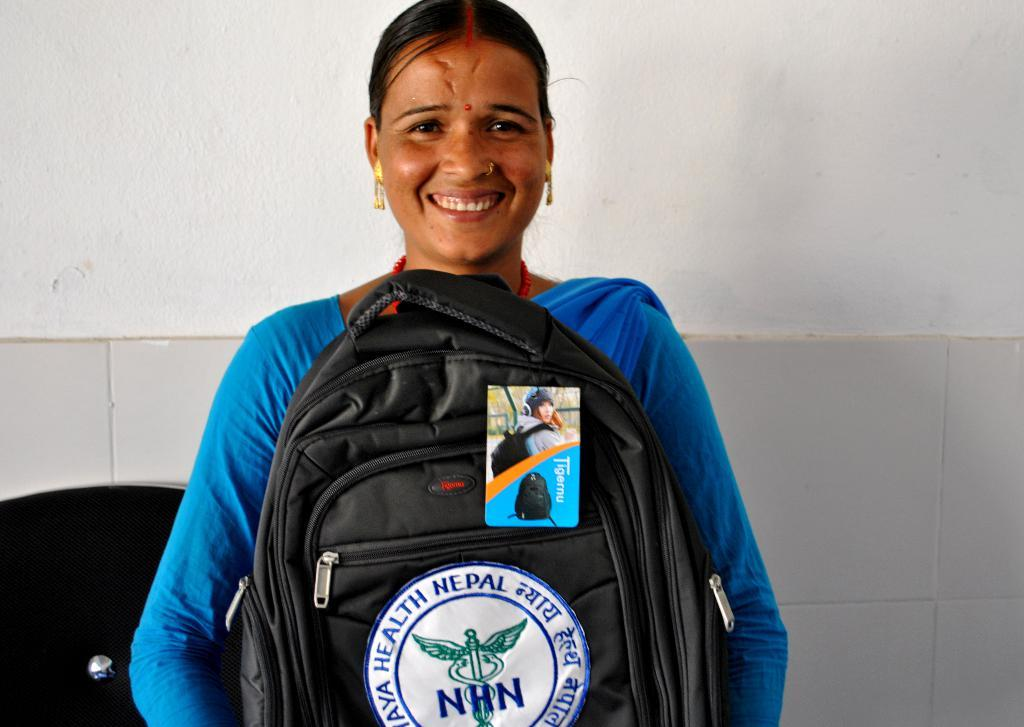<image>
Provide a brief description of the given image. A woman holds a bag with the letters NHN on it. 